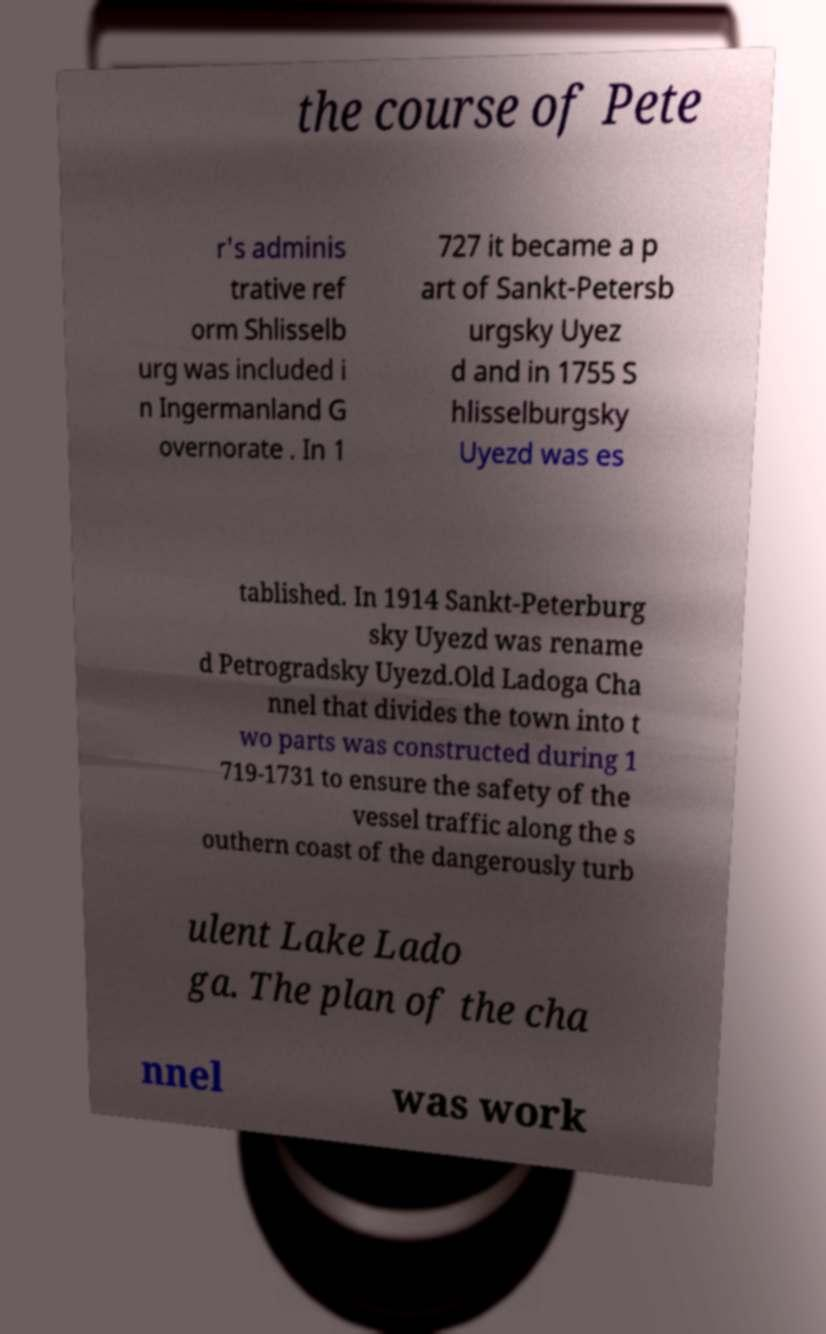I need the written content from this picture converted into text. Can you do that? the course of Pete r's adminis trative ref orm Shlisselb urg was included i n Ingermanland G overnorate . In 1 727 it became a p art of Sankt-Petersb urgsky Uyez d and in 1755 S hlisselburgsky Uyezd was es tablished. In 1914 Sankt-Peterburg sky Uyezd was rename d Petrogradsky Uyezd.Old Ladoga Cha nnel that divides the town into t wo parts was constructed during 1 719-1731 to ensure the safety of the vessel traffic along the s outhern coast of the dangerously turb ulent Lake Lado ga. The plan of the cha nnel was work 